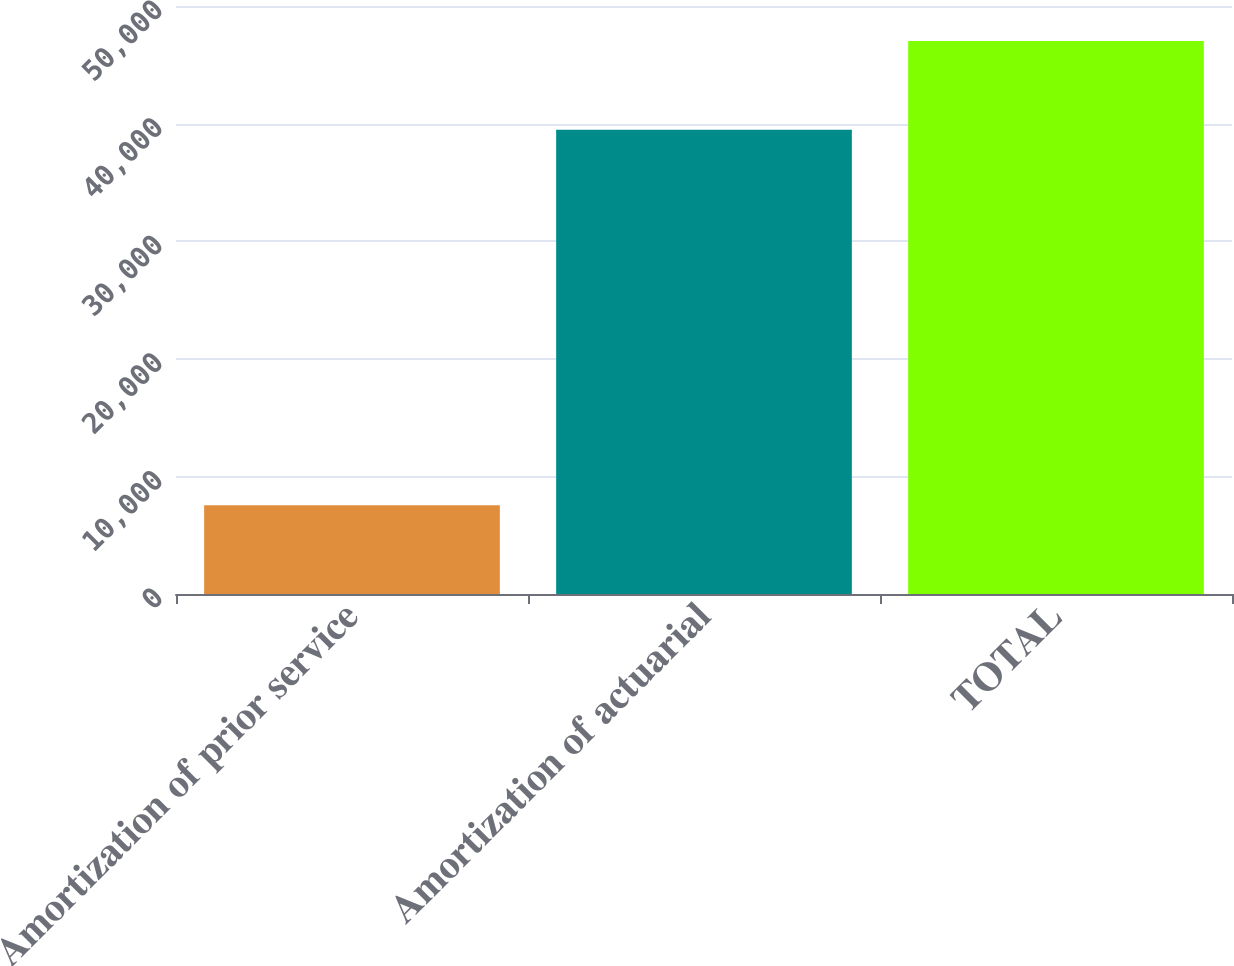<chart> <loc_0><loc_0><loc_500><loc_500><bar_chart><fcel>Amortization of prior service<fcel>Amortization of actuarial<fcel>TOTAL<nl><fcel>7537<fcel>39483<fcel>47020<nl></chart> 